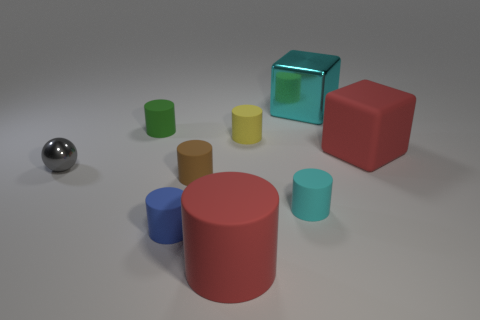Subtract all blue cylinders. How many cylinders are left? 5 Subtract all red cylinders. How many cylinders are left? 5 Add 1 gray objects. How many objects exist? 10 Subtract all brown cylinders. Subtract all blue balls. How many cylinders are left? 5 Subtract all balls. How many objects are left? 8 Add 5 small metal things. How many small metal things are left? 6 Add 5 big cyan metal objects. How many big cyan metal objects exist? 6 Subtract 1 yellow cylinders. How many objects are left? 8 Subtract all small blue objects. Subtract all big cyan metal blocks. How many objects are left? 7 